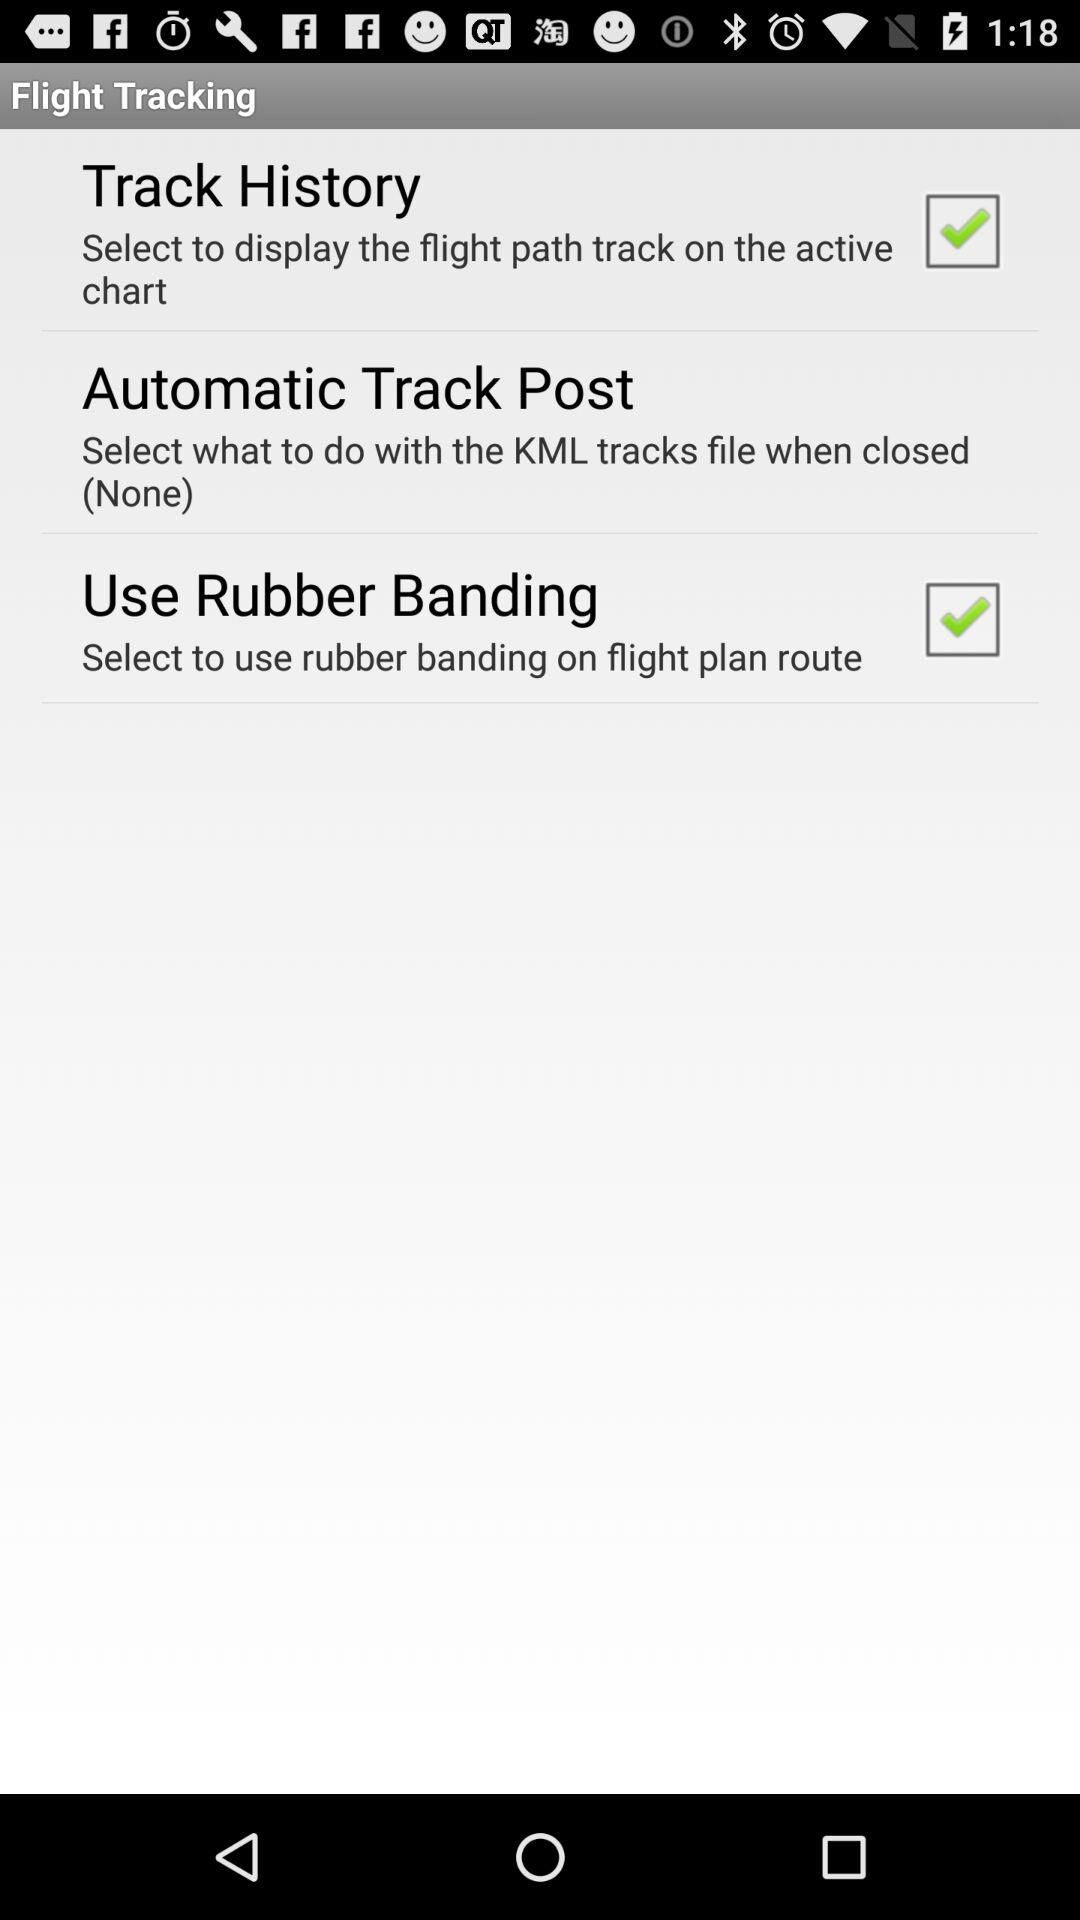Which settings are checked under the flight tracking section? The settings are "Track History" and "Use Rubber Banding". 